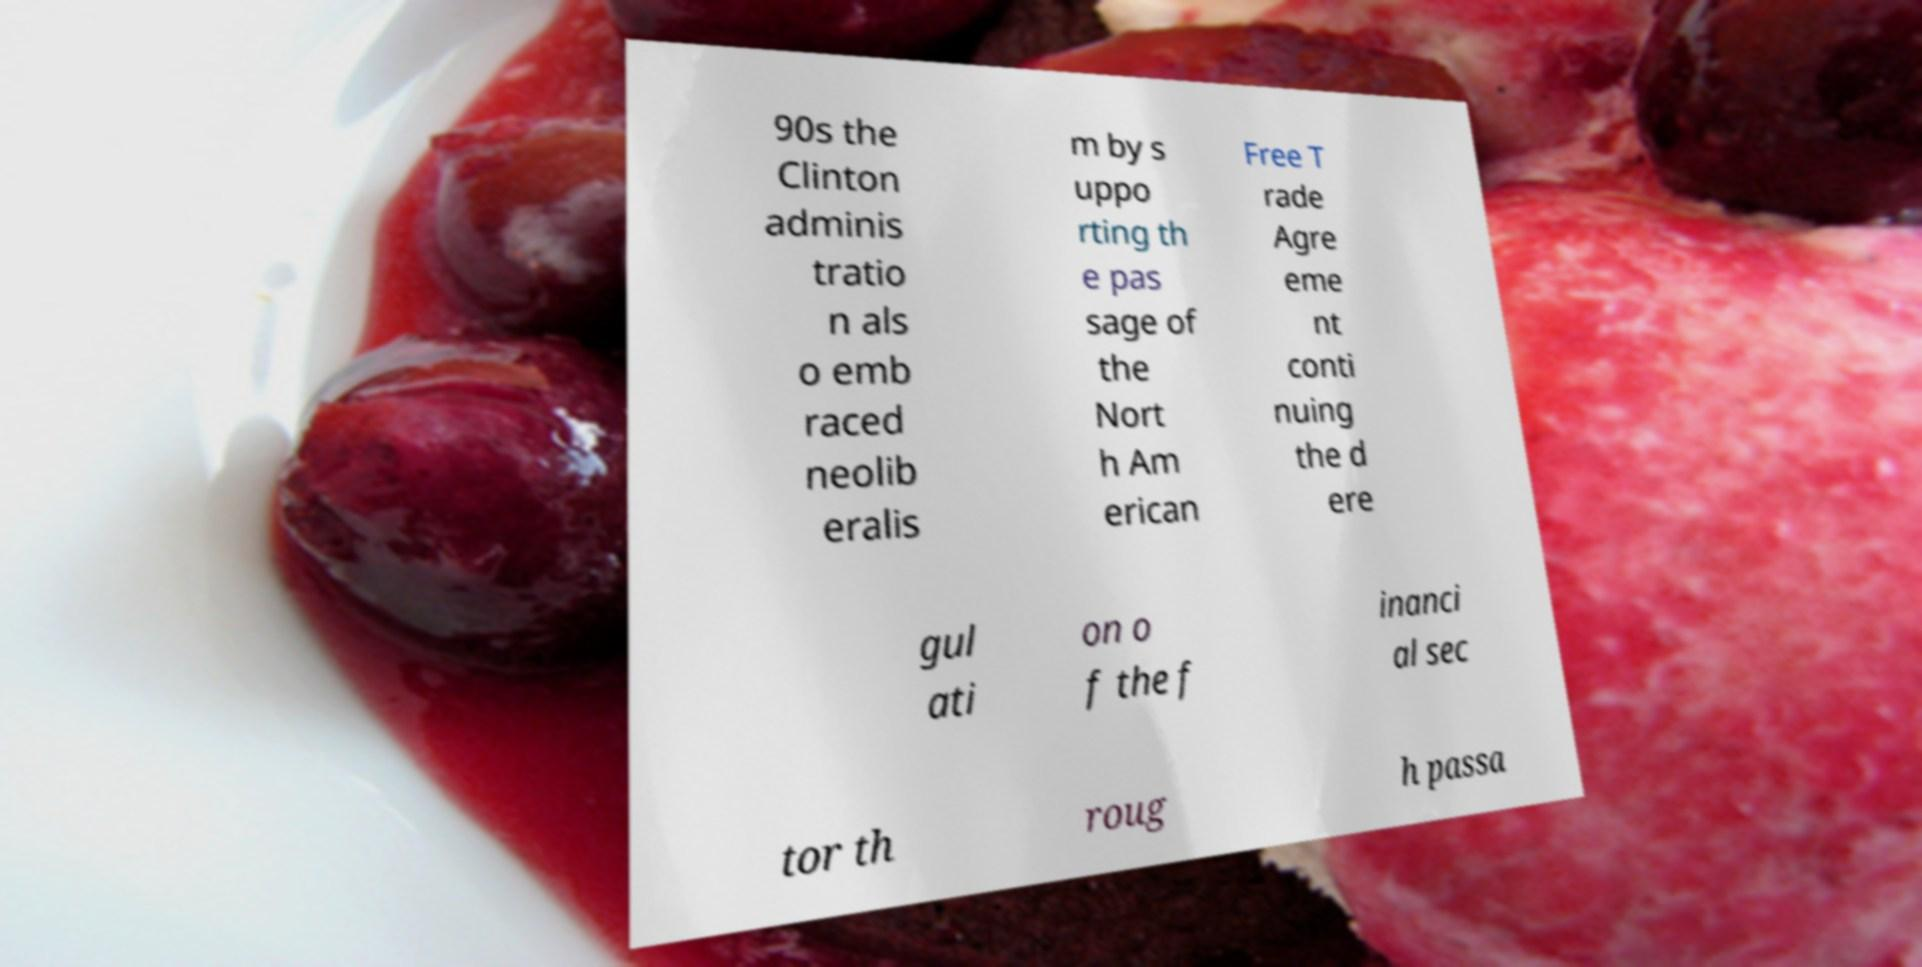Could you assist in decoding the text presented in this image and type it out clearly? 90s the Clinton adminis tratio n als o emb raced neolib eralis m by s uppo rting th e pas sage of the Nort h Am erican Free T rade Agre eme nt conti nuing the d ere gul ati on o f the f inanci al sec tor th roug h passa 